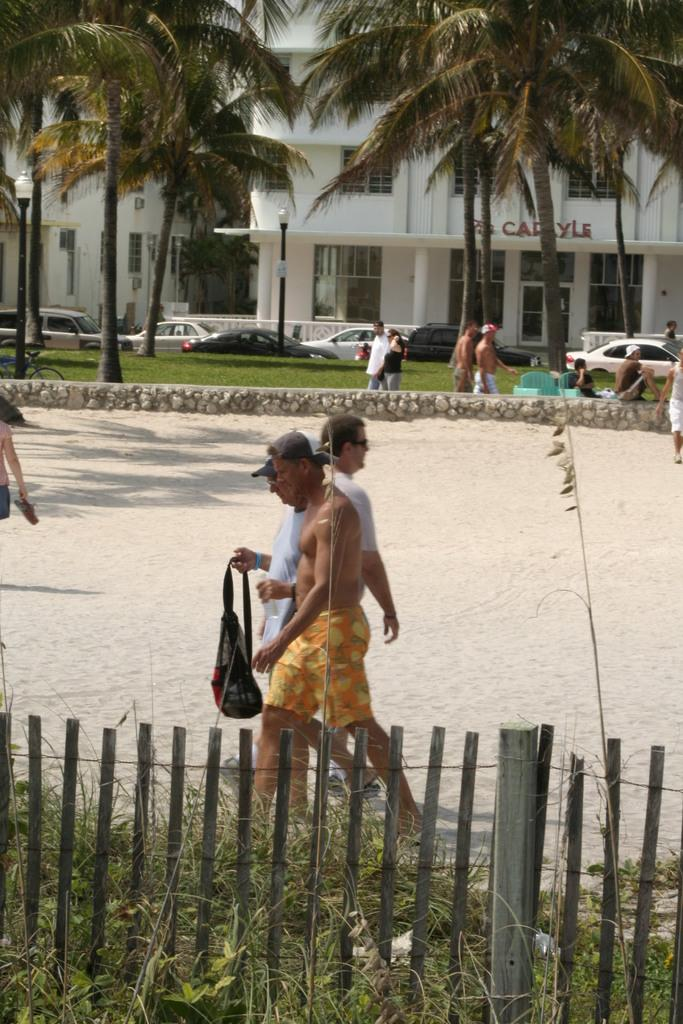How many people are in the image? There are people in the image, but the exact number is not specified. Where are some of the people located in the image? Some of the people are in the sand. What type of vegetation can be seen in the image? There are trees and grass in the image. What types of man-made structures are present in the image? There are vehicles, buildings, a fence, lights on poles, and a small stone wall in the image. Are there any cacti visible in the image? There is no mention of cacti in the provided facts, so we cannot determine if they are present in the image. Can you tell me how many cherries are on the small stone wall? There is no mention of cherries in the provided facts, so we cannot determine if they are present on the small stone wall or anywhere else in the image. 